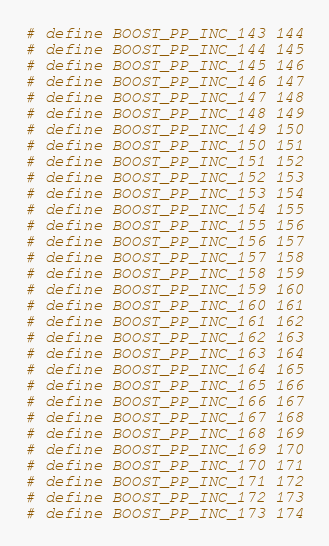Convert code to text. <code><loc_0><loc_0><loc_500><loc_500><_C++_># define BOOST_PP_INC_143 144
# define BOOST_PP_INC_144 145
# define BOOST_PP_INC_145 146
# define BOOST_PP_INC_146 147
# define BOOST_PP_INC_147 148
# define BOOST_PP_INC_148 149
# define BOOST_PP_INC_149 150
# define BOOST_PP_INC_150 151
# define BOOST_PP_INC_151 152
# define BOOST_PP_INC_152 153
# define BOOST_PP_INC_153 154
# define BOOST_PP_INC_154 155
# define BOOST_PP_INC_155 156
# define BOOST_PP_INC_156 157
# define BOOST_PP_INC_157 158
# define BOOST_PP_INC_158 159
# define BOOST_PP_INC_159 160
# define BOOST_PP_INC_160 161
# define BOOST_PP_INC_161 162
# define BOOST_PP_INC_162 163
# define BOOST_PP_INC_163 164
# define BOOST_PP_INC_164 165
# define BOOST_PP_INC_165 166
# define BOOST_PP_INC_166 167
# define BOOST_PP_INC_167 168
# define BOOST_PP_INC_168 169
# define BOOST_PP_INC_169 170
# define BOOST_PP_INC_170 171
# define BOOST_PP_INC_171 172
# define BOOST_PP_INC_172 173
# define BOOST_PP_INC_173 174</code> 